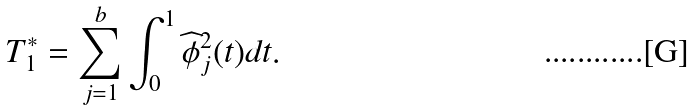<formula> <loc_0><loc_0><loc_500><loc_500>T ^ { * } _ { 1 } = \sum _ { j = 1 } ^ { b } \int _ { 0 } ^ { 1 } \widehat { \phi } ^ { 2 } _ { j } ( t ) d t .</formula> 